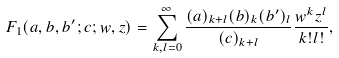<formula> <loc_0><loc_0><loc_500><loc_500>F _ { 1 } ( a , b , b ^ { \prime } ; c ; w , z ) = \sum _ { k , l = 0 } ^ { \infty } \frac { ( a ) _ { k + l } ( b ) _ { k } ( b ^ { \prime } ) _ { l } } { ( c ) _ { k + l } } \frac { w ^ { k } z ^ { l } } { k ! l ! } ,</formula> 